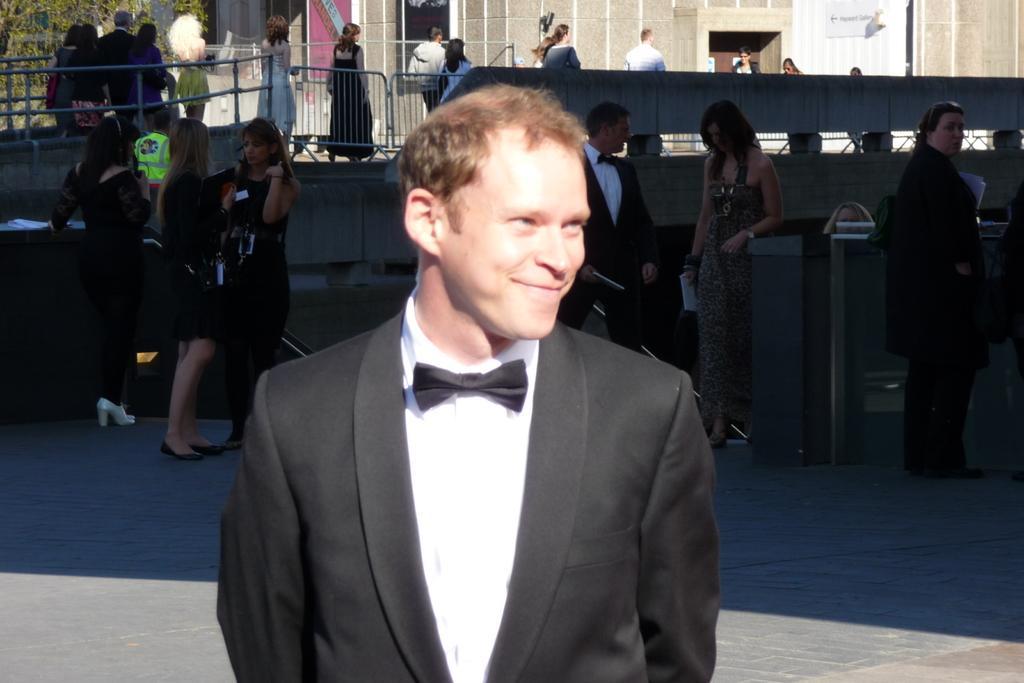Describe this image in one or two sentences. In this image we can see people standing on the road and some are walking on the road. In the background there are buildings, trees and grills. 